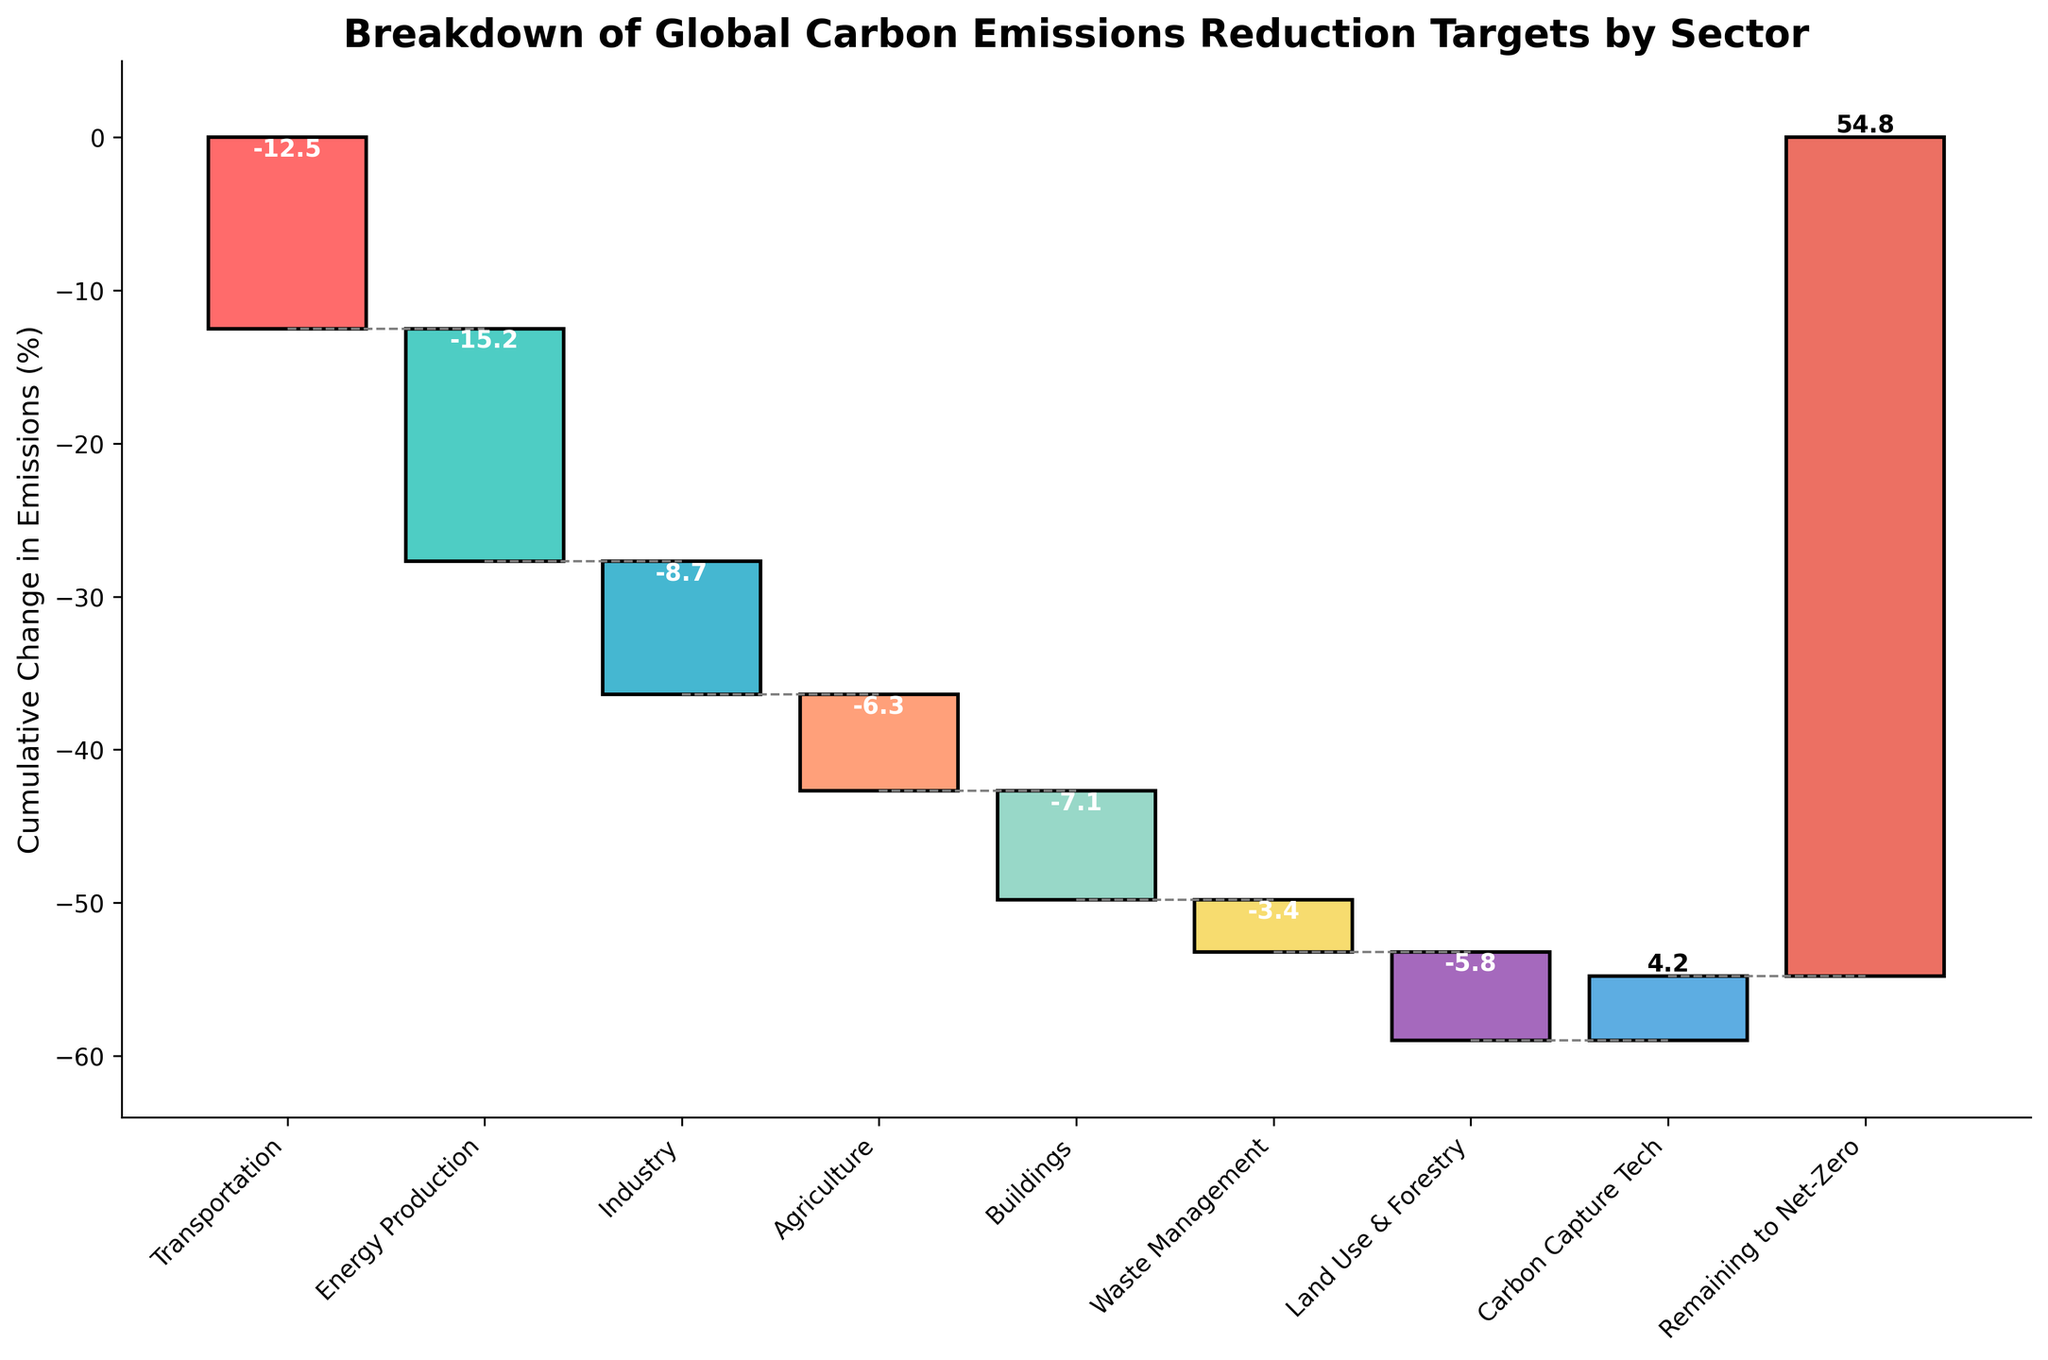What's the title of the chart? The title of the chart is displayed at the top and reads "Breakdown of Global Carbon Emissions Reduction Targets by Sector".
Answer: Breakdown of Global Carbon Emissions Reduction Targets by Sector What is the cumulative emissions change for Energy Production? The cumulative emissions change for Energy Production is found by summing the emissions reductions up to that point: Transportation (-12.5) + Energy Production (-15.2) = -27.7.
Answer: -27.7 Which sector contributes the most to emissions reduction? By observing the bar lengths and numerical values, it’s evident that the sector with the largest negative value contributes most to emissions reduction. Energy Production has the largest reduction at -15.2.
Answer: Energy Production How much additional effort is required to achieve net-zero emissions after accounting for Carbon Capture Tech? The "Remaining to Net-Zero" value shows the remaining effort necessary. This value is 54.8%.
Answer: 54.8% What's the cumulative emissions change after Carbon Capture Tech is included? Adding the positive effect of Carbon Capture Tech (4.2) to the previous cumulative values up to Land Use & Forestry: Cumulative up to Land Use & Forestry is -53.6, then -53.6 + 4.2 = -49.4.
Answer: -49.4 Which sectors have net positive impacts on emissions? Check the sectors with positive bar values. Carbon Capture Tech is the only sector with a positive impact, indicated by a value of 4.2.
Answer: Carbon Capture Tech What is the total reduction from the top three sectors contributing most to emission reductions? Sum the three largest negative sector values: Energy Production (-15.2), Transportation (-12.5), and Industry (-8.7). -15.2 + -12.5 + -8.7 = -36.4.
Answer: -36.4 Is the cumulative change in emissions negative or positive after considering all sectors up to Waste Management? Calculate cumulative change up to Waste Management: -12.5 (Transportation) - 15.2 (Energy Production) - 8.7 (Industry) - 6.3 (Agriculture) - 7.1 (Buildings) - 3.4 (Waste Management) = -53.2. Since -53.2 is negative, the cumulative change is negative.
Answer: Negative Which sector has the second smallest reduction in emissions? The reduction values in ascending order are: Carbon Capture Tech (not a reduction), Waste Management (-3.4), Land Use & Forestry (-5.8), Agriculture (-6.3), Buildings (-7.1), Industry (-8.7), Transportation (-12.5), Energy Production (-15.2). The second smallest reduction is Land Use & Forestry at -5.8.
Answer: Land Use & Forestry What is the visual difference between sectors that reduce emissions and Carbon Capture Tech, which increases them? Sectors reducing emissions have negative values, shown as bars extending downwards starting from a cumulative baseline. Carbon Capture Tech has a positive value, shown as a bar extending upwards from the baseline.
Answer: Emission-reducing sectors have downward bars; Carbon Capture Tech has an upward bar 